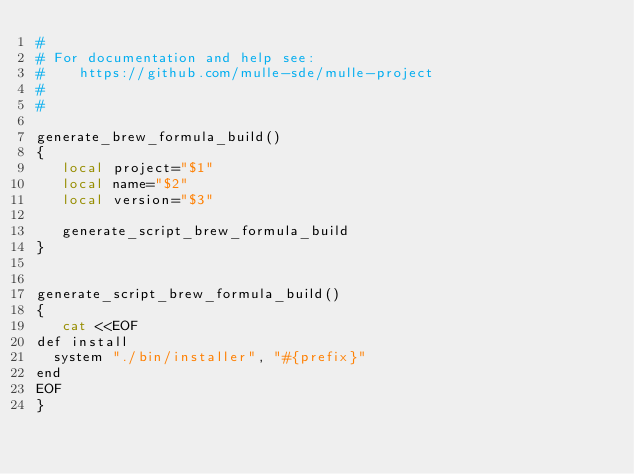Convert code to text. <code><loc_0><loc_0><loc_500><loc_500><_Bash_>#
# For documentation and help see:
#    https://github.com/mulle-sde/mulle-project
#
#

generate_brew_formula_build()
{
   local project="$1"
   local name="$2"
   local version="$3"

   generate_script_brew_formula_build
}


generate_script_brew_formula_build()
{
   cat <<EOF
def install
  system "./bin/installer", "#{prefix}"
end
EOF
}

</code> 